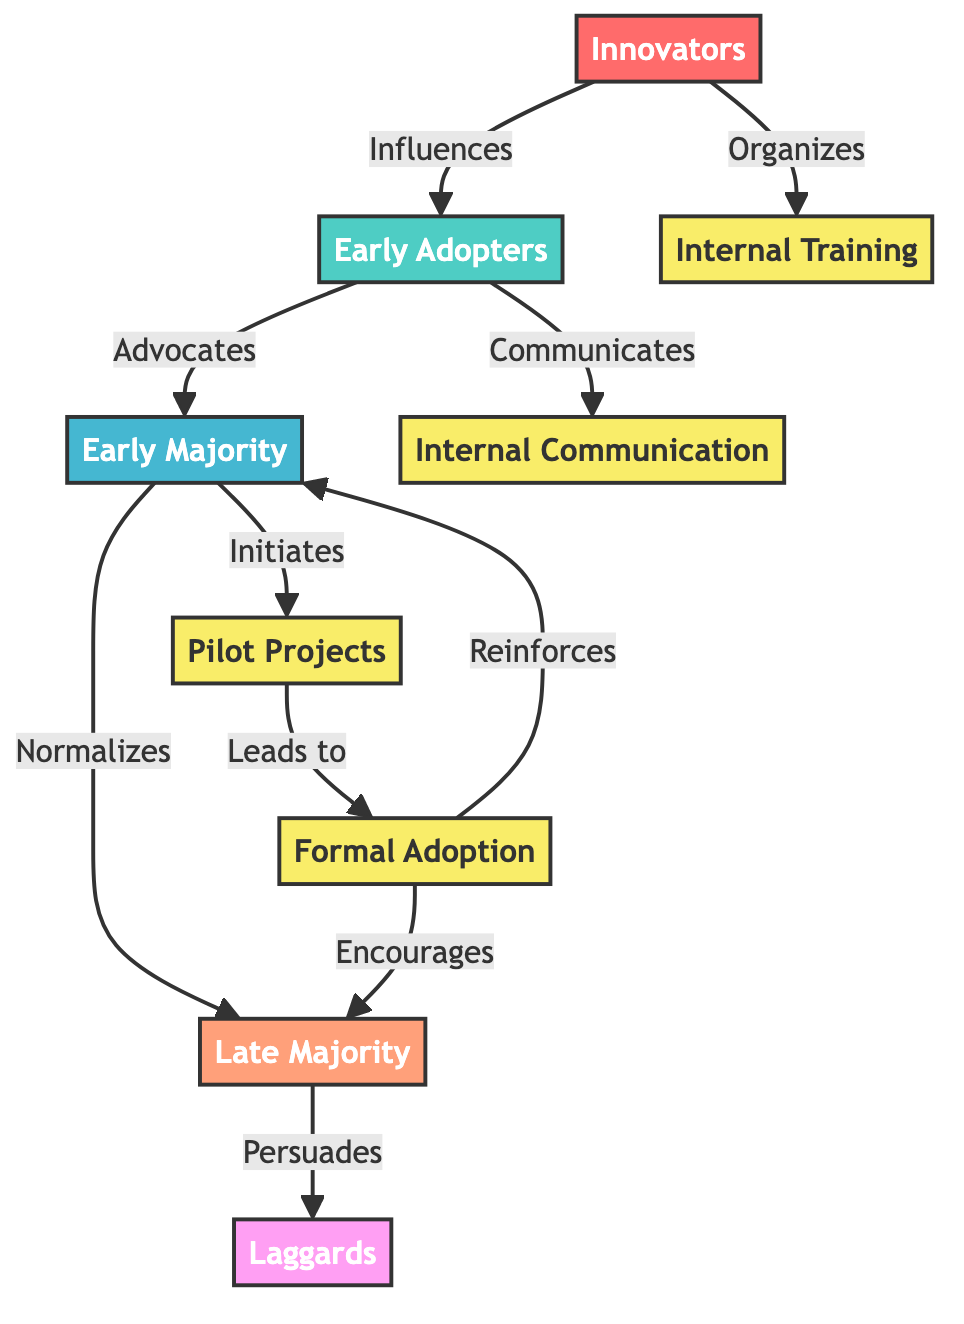What's the first node in the diagram? The first node in the diagram, indicating the starting point of the technology adoption lifecycle, is labeled "Innovators."
Answer: Innovators How many major categories are represented in the diagram? The diagram categorizes individuals into five major categories of technology adoption: Innovators, Early Adopters, Early Majority, Late Majority, and Laggards, indicating a total of five categories.
Answer: Five What role do Early Adopters play in the adoption process? Early Adopters are described as advocates in the flow of the diagram, influencing the next category, Early Majority, to adopt the technology.
Answer: Advocates Which node leads to Formal Adoption? "Pilot Projects" is the process that leads to the node labeled "Formal Adoption," signifying a structured approach to integrating the technology.
Answer: Pilot Projects How many processes are outlined in the diagram? There are four processes identified in the diagram: Internal Training, Internal Communication, Pilot Projects, and Formal Adoption, totaling four processes.
Answer: Four What influence do Innovators have on the diagram? Innovators organize internal training and influence Early Adopters, showcasing their pivotal role in initiating the adoption process for new software tools within the organization.
Answer: Organizes What occurs after Formal Adoption according to the diagram? After Formal Adoption, the diagram indicates that it reinforces the Early Majority and encourages the Late Majority, showing an ongoing influence on subsequent adoption categories.
Answer: Reinforces and Encourages What visual style distinguishes Laggards in the diagram? Laggards are visually represented with a fill color of #FF9FF3, which is a specific pink shade, making them distinct from other nodes in the diagram.
Answer: Pink shade Why is the connection from Early Majority to Late Majority labeled "Persuades"? The labeled connection suggests that the integration and acceptance demonstrated by the Early Majority serve to persuade the Late Majority to adopt the technology, illustrating a social influence dynamic.
Answer: Persuades 